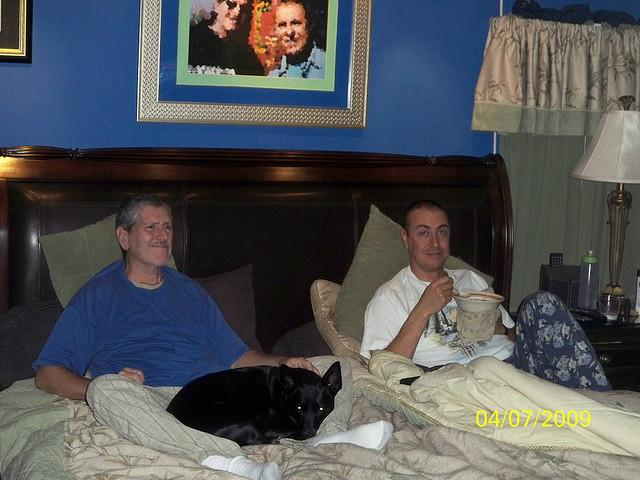How are these men related?

Choices:
A) lovers
B) arch villians
C) siblings
D) enemies lovers 